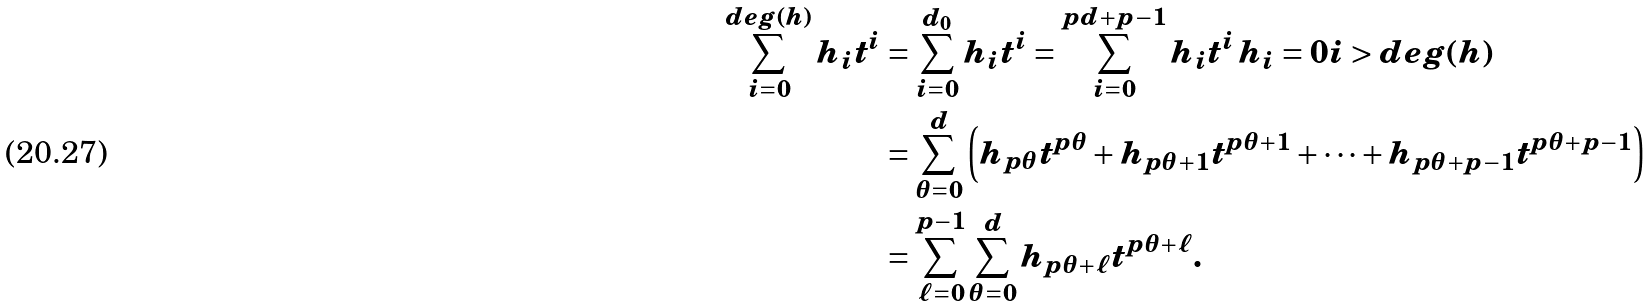Convert formula to latex. <formula><loc_0><loc_0><loc_500><loc_500>\sum _ { i = 0 } ^ { d e g ( h ) } h _ { i } t ^ { i } & = \sum _ { i = 0 } ^ { d _ { 0 } } h _ { i } t ^ { i } = \sum _ { i = 0 } ^ { p d + p - 1 } h _ { i } t ^ { i } \, h _ { i } = 0 i > d e g ( h ) \\ & = \sum _ { \theta = 0 } ^ { d } \left ( h _ { p \theta } t ^ { p \theta } + h _ { p \theta + 1 } t ^ { p \theta + 1 } + \cdots + h _ { p \theta + p - 1 } t ^ { p \theta + p - 1 } \right ) \\ & = \sum _ { \ell = 0 } ^ { p - 1 } \sum _ { \theta = 0 } ^ { d } h _ { p \theta + \ell } t ^ { p \theta + \ell } .</formula> 